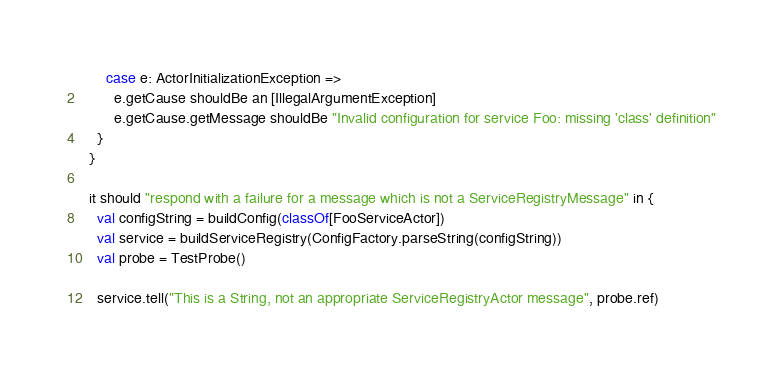<code> <loc_0><loc_0><loc_500><loc_500><_Scala_>      case e: ActorInitializationException =>
        e.getCause shouldBe an [IllegalArgumentException]
        e.getCause.getMessage shouldBe "Invalid configuration for service Foo: missing 'class' definition"
    }
  }

  it should "respond with a failure for a message which is not a ServiceRegistryMessage" in {
    val configString = buildConfig(classOf[FooServiceActor])
    val service = buildServiceRegistry(ConfigFactory.parseString(configString))
    val probe = TestProbe()

    service.tell("This is a String, not an appropriate ServiceRegistryActor message", probe.ref)
</code> 